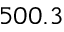Convert formula to latex. <formula><loc_0><loc_0><loc_500><loc_500>5 0 0 . 3</formula> 